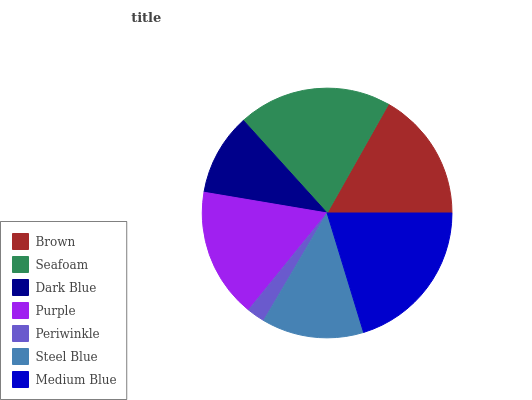Is Periwinkle the minimum?
Answer yes or no. Yes. Is Medium Blue the maximum?
Answer yes or no. Yes. Is Seafoam the minimum?
Answer yes or no. No. Is Seafoam the maximum?
Answer yes or no. No. Is Seafoam greater than Brown?
Answer yes or no. Yes. Is Brown less than Seafoam?
Answer yes or no. Yes. Is Brown greater than Seafoam?
Answer yes or no. No. Is Seafoam less than Brown?
Answer yes or no. No. Is Purple the high median?
Answer yes or no. Yes. Is Purple the low median?
Answer yes or no. Yes. Is Periwinkle the high median?
Answer yes or no. No. Is Seafoam the low median?
Answer yes or no. No. 